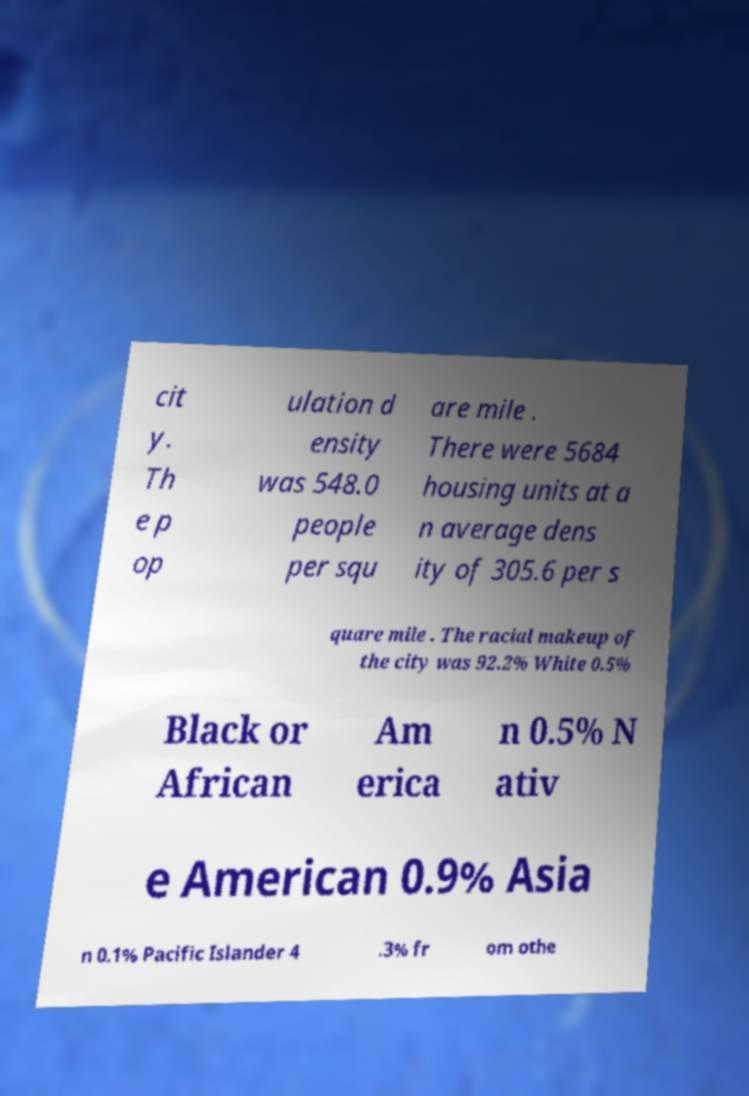Could you assist in decoding the text presented in this image and type it out clearly? cit y. Th e p op ulation d ensity was 548.0 people per squ are mile . There were 5684 housing units at a n average dens ity of 305.6 per s quare mile . The racial makeup of the city was 92.2% White 0.5% Black or African Am erica n 0.5% N ativ e American 0.9% Asia n 0.1% Pacific Islander 4 .3% fr om othe 